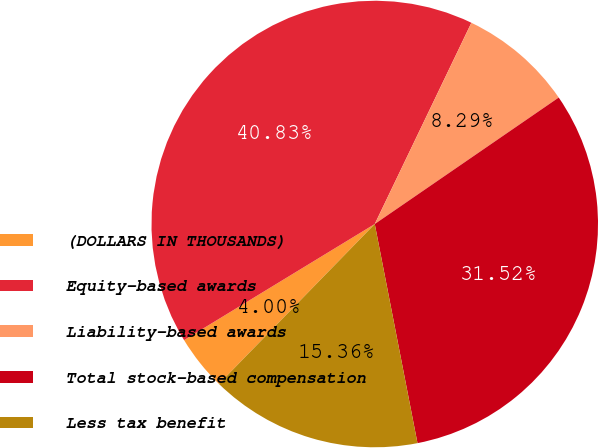Convert chart. <chart><loc_0><loc_0><loc_500><loc_500><pie_chart><fcel>(DOLLARS IN THOUSANDS)<fcel>Equity-based awards<fcel>Liability-based awards<fcel>Total stock-based compensation<fcel>Less tax benefit<nl><fcel>4.0%<fcel>40.83%<fcel>8.29%<fcel>31.52%<fcel>15.36%<nl></chart> 